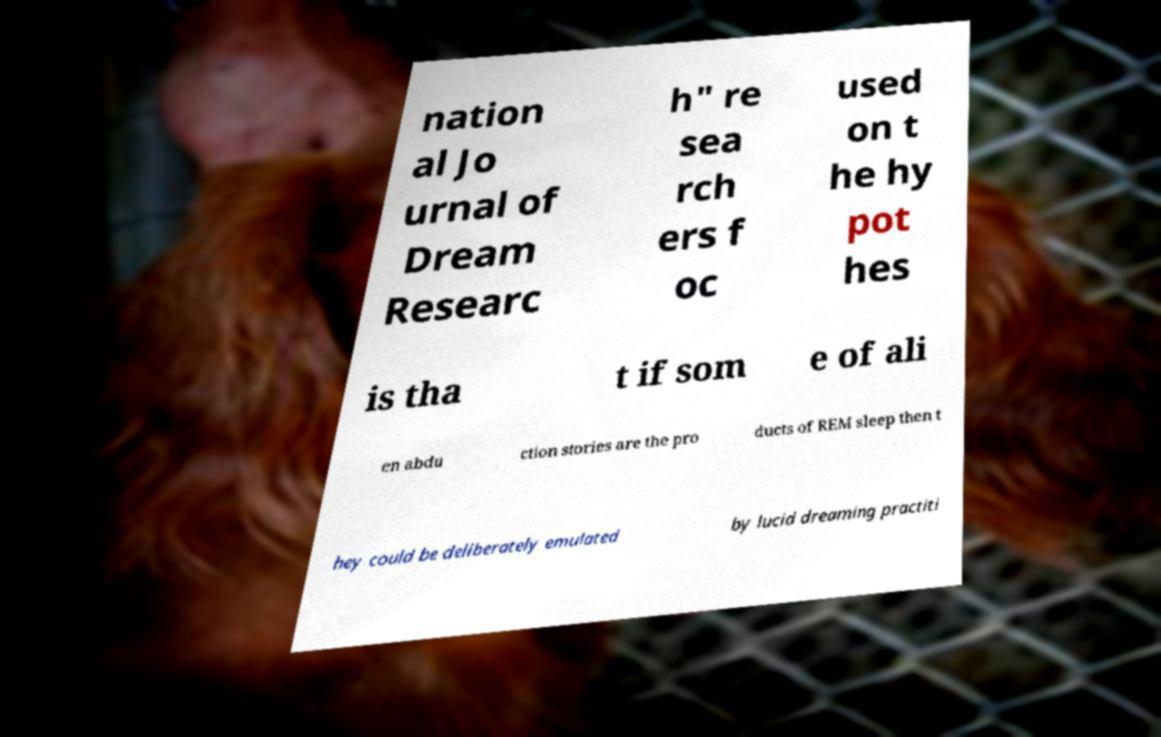Could you extract and type out the text from this image? nation al Jo urnal of Dream Researc h" re sea rch ers f oc used on t he hy pot hes is tha t if som e of ali en abdu ction stories are the pro ducts of REM sleep then t hey could be deliberately emulated by lucid dreaming practiti 